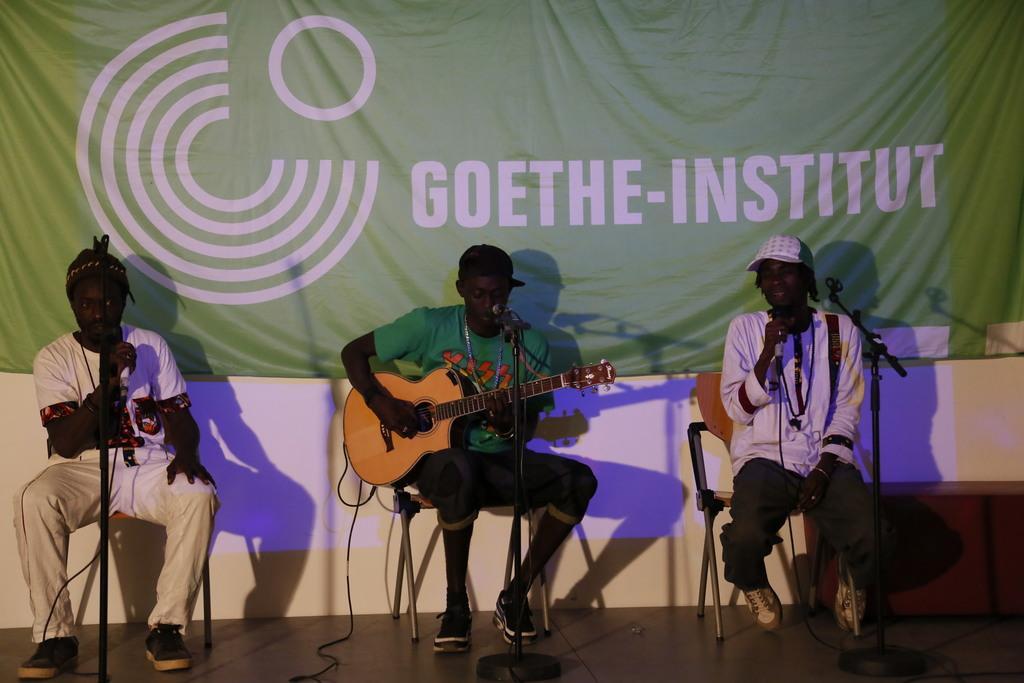Could you give a brief overview of what you see in this image? There are three people in the image. On the left there is a man he is holding a mic in his hand. In the center the man is playing a guitar. On the right the man is singing a song. There are mics placed before them. In the background there is a board. 